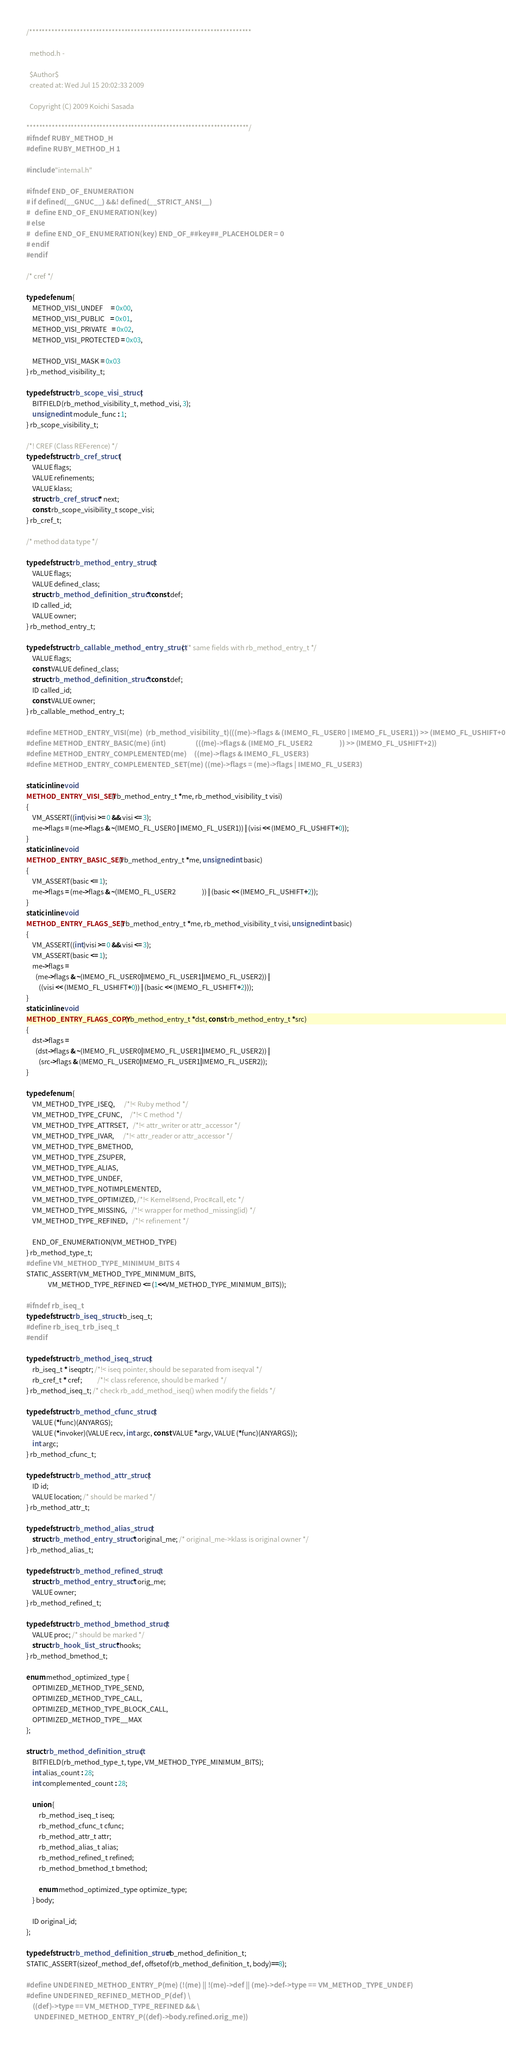<code> <loc_0><loc_0><loc_500><loc_500><_C_>/**********************************************************************

  method.h -

  $Author$
  created at: Wed Jul 15 20:02:33 2009

  Copyright (C) 2009 Koichi Sasada

**********************************************************************/
#ifndef RUBY_METHOD_H
#define RUBY_METHOD_H 1

#include "internal.h"

#ifndef END_OF_ENUMERATION
# if defined(__GNUC__) &&! defined(__STRICT_ANSI__)
#   define END_OF_ENUMERATION(key)
# else
#   define END_OF_ENUMERATION(key) END_OF_##key##_PLACEHOLDER = 0
# endif
#endif

/* cref */

typedef enum {
    METHOD_VISI_UNDEF     = 0x00,
    METHOD_VISI_PUBLIC    = 0x01,
    METHOD_VISI_PRIVATE   = 0x02,
    METHOD_VISI_PROTECTED = 0x03,

    METHOD_VISI_MASK = 0x03
} rb_method_visibility_t;

typedef struct rb_scope_visi_struct {
    BITFIELD(rb_method_visibility_t, method_visi, 3);
    unsigned int module_func : 1;
} rb_scope_visibility_t;

/*! CREF (Class REFerence) */
typedef struct rb_cref_struct {
    VALUE flags;
    VALUE refinements;
    VALUE klass;
    struct rb_cref_struct * next;
    const rb_scope_visibility_t scope_visi;
} rb_cref_t;

/* method data type */

typedef struct rb_method_entry_struct {
    VALUE flags;
    VALUE defined_class;
    struct rb_method_definition_struct * const def;
    ID called_id;
    VALUE owner;
} rb_method_entry_t;

typedef struct rb_callable_method_entry_struct { /* same fields with rb_method_entry_t */
    VALUE flags;
    const VALUE defined_class;
    struct rb_method_definition_struct * const def;
    ID called_id;
    const VALUE owner;
} rb_callable_method_entry_t;

#define METHOD_ENTRY_VISI(me)  (rb_method_visibility_t)(((me)->flags & (IMEMO_FL_USER0 | IMEMO_FL_USER1)) >> (IMEMO_FL_USHIFT+0))
#define METHOD_ENTRY_BASIC(me) (int)                   (((me)->flags & (IMEMO_FL_USER2                 )) >> (IMEMO_FL_USHIFT+2))
#define METHOD_ENTRY_COMPLEMENTED(me)     ((me)->flags & IMEMO_FL_USER3)
#define METHOD_ENTRY_COMPLEMENTED_SET(me) ((me)->flags = (me)->flags | IMEMO_FL_USER3)

static inline void
METHOD_ENTRY_VISI_SET(rb_method_entry_t *me, rb_method_visibility_t visi)
{
    VM_ASSERT((int)visi >= 0 && visi <= 3);
    me->flags = (me->flags & ~(IMEMO_FL_USER0 | IMEMO_FL_USER1)) | (visi << (IMEMO_FL_USHIFT+0));
}
static inline void
METHOD_ENTRY_BASIC_SET(rb_method_entry_t *me, unsigned int basic)
{
    VM_ASSERT(basic <= 1);
    me->flags = (me->flags & ~(IMEMO_FL_USER2                 )) | (basic << (IMEMO_FL_USHIFT+2));
}
static inline void
METHOD_ENTRY_FLAGS_SET(rb_method_entry_t *me, rb_method_visibility_t visi, unsigned int basic)
{
    VM_ASSERT((int)visi >= 0 && visi <= 3);
    VM_ASSERT(basic <= 1);
    me->flags =
      (me->flags & ~(IMEMO_FL_USER0|IMEMO_FL_USER1|IMEMO_FL_USER2)) |
        ((visi << (IMEMO_FL_USHIFT+0)) | (basic << (IMEMO_FL_USHIFT+2)));
}
static inline void
METHOD_ENTRY_FLAGS_COPY(rb_method_entry_t *dst, const rb_method_entry_t *src)
{
    dst->flags =
      (dst->flags & ~(IMEMO_FL_USER0|IMEMO_FL_USER1|IMEMO_FL_USER2)) |
        (src->flags & (IMEMO_FL_USER0|IMEMO_FL_USER1|IMEMO_FL_USER2));
}

typedef enum {
    VM_METHOD_TYPE_ISEQ,      /*!< Ruby method */
    VM_METHOD_TYPE_CFUNC,     /*!< C method */
    VM_METHOD_TYPE_ATTRSET,   /*!< attr_writer or attr_accessor */
    VM_METHOD_TYPE_IVAR,      /*!< attr_reader or attr_accessor */
    VM_METHOD_TYPE_BMETHOD,
    VM_METHOD_TYPE_ZSUPER,
    VM_METHOD_TYPE_ALIAS,
    VM_METHOD_TYPE_UNDEF,
    VM_METHOD_TYPE_NOTIMPLEMENTED,
    VM_METHOD_TYPE_OPTIMIZED, /*!< Kernel#send, Proc#call, etc */
    VM_METHOD_TYPE_MISSING,   /*!< wrapper for method_missing(id) */
    VM_METHOD_TYPE_REFINED,   /*!< refinement */

    END_OF_ENUMERATION(VM_METHOD_TYPE)
} rb_method_type_t;
#define VM_METHOD_TYPE_MINIMUM_BITS 4
STATIC_ASSERT(VM_METHOD_TYPE_MINIMUM_BITS,
              VM_METHOD_TYPE_REFINED <= (1<<VM_METHOD_TYPE_MINIMUM_BITS));

#ifndef rb_iseq_t
typedef struct rb_iseq_struct rb_iseq_t;
#define rb_iseq_t rb_iseq_t
#endif

typedef struct rb_method_iseq_struct {
    rb_iseq_t * iseqptr; /*!< iseq pointer, should be separated from iseqval */
    rb_cref_t * cref;          /*!< class reference, should be marked */
} rb_method_iseq_t; /* check rb_add_method_iseq() when modify the fields */

typedef struct rb_method_cfunc_struct {
    VALUE (*func)(ANYARGS);
    VALUE (*invoker)(VALUE recv, int argc, const VALUE *argv, VALUE (*func)(ANYARGS));
    int argc;
} rb_method_cfunc_t;

typedef struct rb_method_attr_struct {
    ID id;
    VALUE location; /* should be marked */
} rb_method_attr_t;

typedef struct rb_method_alias_struct {
    struct rb_method_entry_struct * original_me; /* original_me->klass is original owner */
} rb_method_alias_t;

typedef struct rb_method_refined_struct {
    struct rb_method_entry_struct * orig_me;
    VALUE owner;
} rb_method_refined_t;

typedef struct rb_method_bmethod_struct {
    VALUE proc; /* should be marked */
    struct rb_hook_list_struct *hooks;
} rb_method_bmethod_t;

enum method_optimized_type {
    OPTIMIZED_METHOD_TYPE_SEND,
    OPTIMIZED_METHOD_TYPE_CALL,
    OPTIMIZED_METHOD_TYPE_BLOCK_CALL,
    OPTIMIZED_METHOD_TYPE__MAX
};

struct rb_method_definition_struct {
    BITFIELD(rb_method_type_t, type, VM_METHOD_TYPE_MINIMUM_BITS);
    int alias_count : 28;
    int complemented_count : 28;

    union {
        rb_method_iseq_t iseq;
        rb_method_cfunc_t cfunc;
        rb_method_attr_t attr;
        rb_method_alias_t alias;
        rb_method_refined_t refined;
        rb_method_bmethod_t bmethod;

        enum method_optimized_type optimize_type;
    } body;

    ID original_id;
};

typedef struct rb_method_definition_struct rb_method_definition_t;
STATIC_ASSERT(sizeof_method_def, offsetof(rb_method_definition_t, body)==8);

#define UNDEFINED_METHOD_ENTRY_P(me) (!(me) || !(me)->def || (me)->def->type == VM_METHOD_TYPE_UNDEF)
#define UNDEFINED_REFINED_METHOD_P(def) \
    ((def)->type == VM_METHOD_TYPE_REFINED && \
     UNDEFINED_METHOD_ENTRY_P((def)->body.refined.orig_me))
</code> 